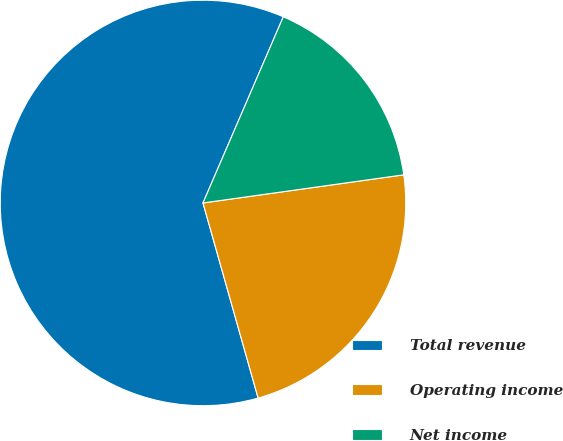<chart> <loc_0><loc_0><loc_500><loc_500><pie_chart><fcel>Total revenue<fcel>Operating income<fcel>Net income<nl><fcel>60.86%<fcel>22.83%<fcel>16.3%<nl></chart> 